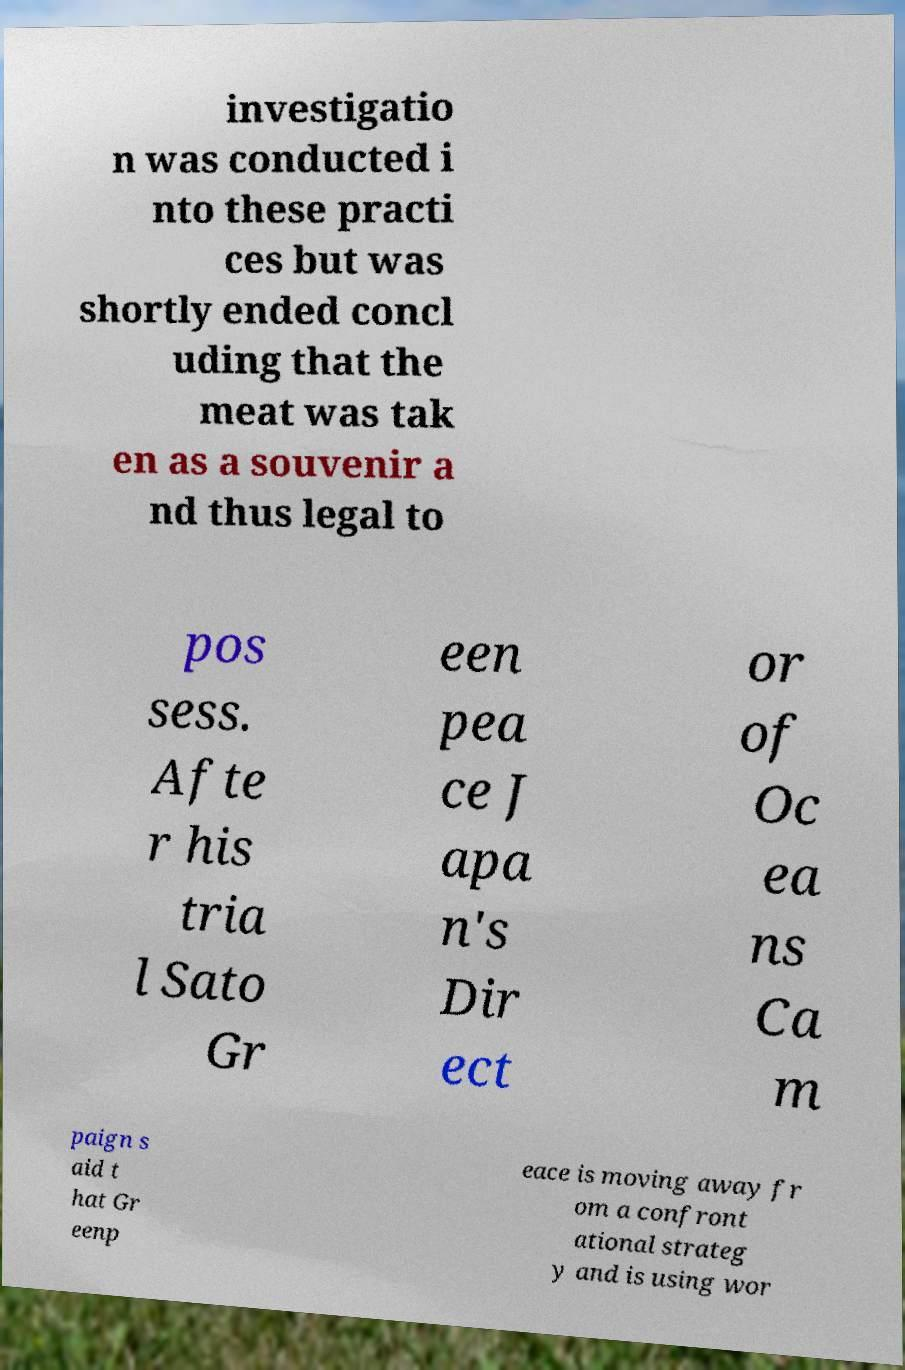Please read and relay the text visible in this image. What does it say? investigatio n was conducted i nto these practi ces but was shortly ended concl uding that the meat was tak en as a souvenir a nd thus legal to pos sess. Afte r his tria l Sato Gr een pea ce J apa n's Dir ect or of Oc ea ns Ca m paign s aid t hat Gr eenp eace is moving away fr om a confront ational strateg y and is using wor 